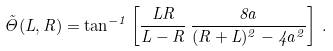Convert formula to latex. <formula><loc_0><loc_0><loc_500><loc_500>\tilde { \Theta } ( L , R ) = \tan ^ { - 1 } \left [ \frac { L R } { L - R } \, \frac { 8 a } { ( R + L ) ^ { 2 } - 4 a ^ { 2 } } \right ] \, .</formula> 